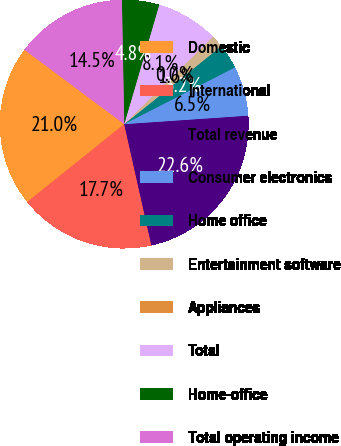Convert chart to OTSL. <chart><loc_0><loc_0><loc_500><loc_500><pie_chart><fcel>Domestic<fcel>International<fcel>Total revenue<fcel>Consumer electronics<fcel>Home office<fcel>Entertainment software<fcel>Appliances<fcel>Total<fcel>Home-office<fcel>Total operating income<nl><fcel>20.96%<fcel>17.74%<fcel>22.58%<fcel>6.45%<fcel>3.23%<fcel>1.62%<fcel>0.0%<fcel>8.07%<fcel>4.84%<fcel>14.51%<nl></chart> 